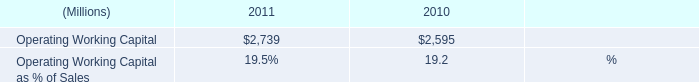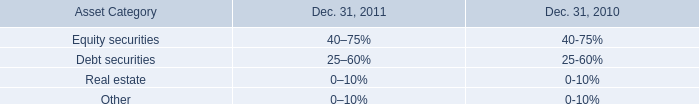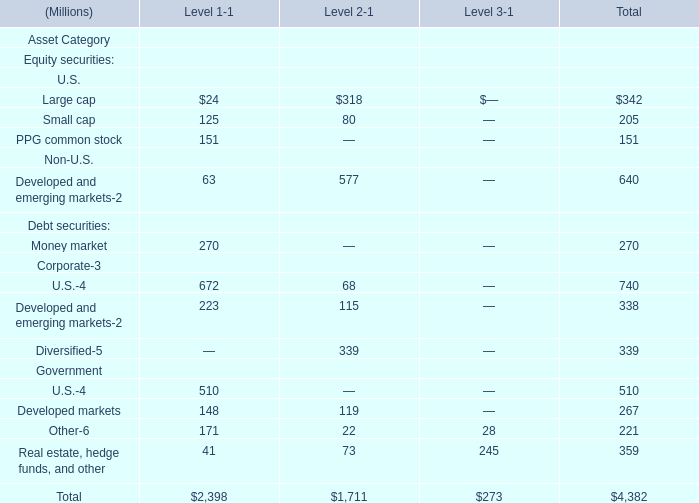what was the percentage change in cash from operating activities from 2010 to 2011? 
Computations: ((1436 - 1310) / 1310)
Answer: 0.09618. 